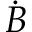Convert formula to latex. <formula><loc_0><loc_0><loc_500><loc_500>\dot { B }</formula> 